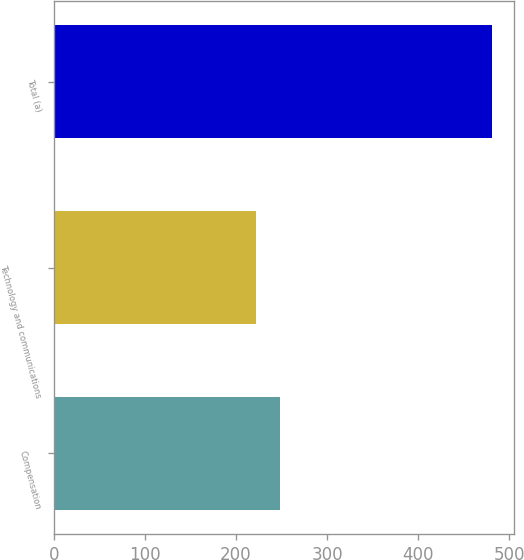Convert chart to OTSL. <chart><loc_0><loc_0><loc_500><loc_500><bar_chart><fcel>Compensation<fcel>Technology and communications<fcel>Total (a)<nl><fcel>247.9<fcel>222<fcel>481<nl></chart> 